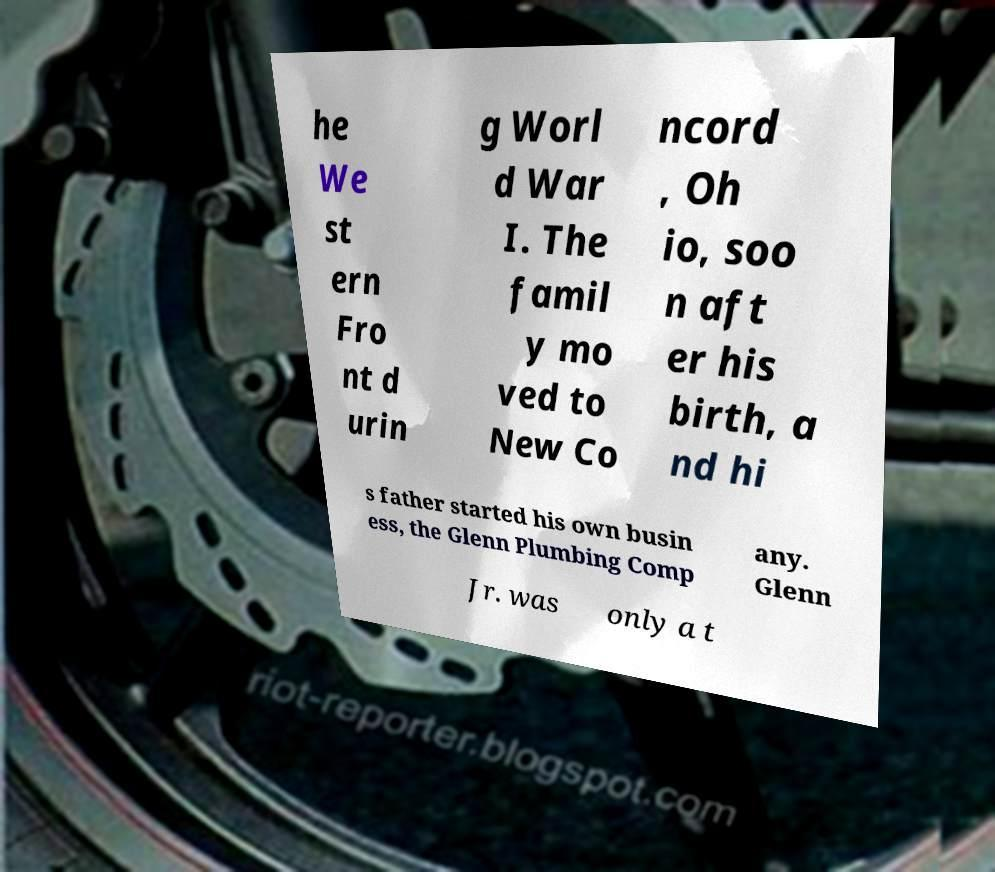Can you accurately transcribe the text from the provided image for me? he We st ern Fro nt d urin g Worl d War I. The famil y mo ved to New Co ncord , Oh io, soo n aft er his birth, a nd hi s father started his own busin ess, the Glenn Plumbing Comp any. Glenn Jr. was only a t 